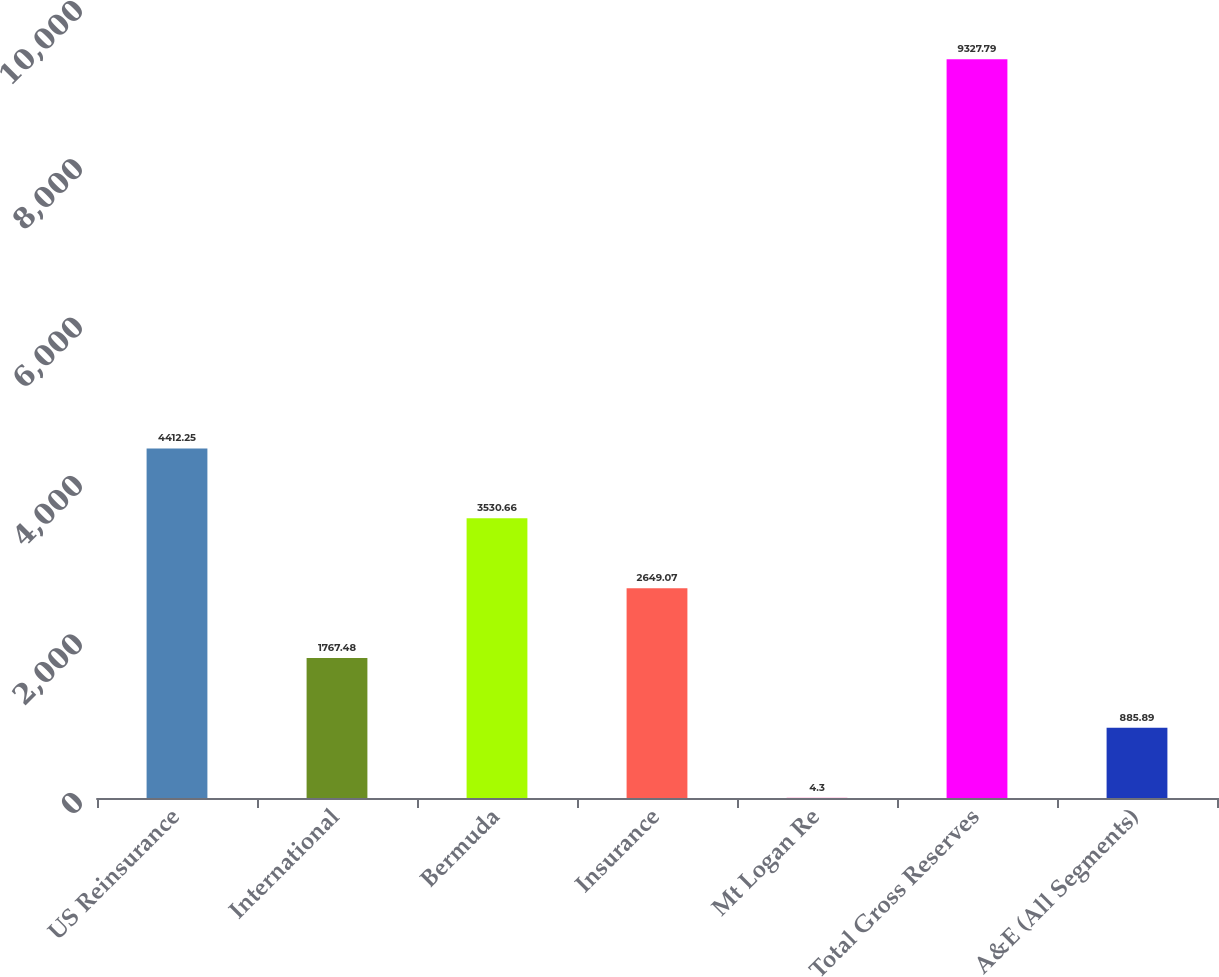<chart> <loc_0><loc_0><loc_500><loc_500><bar_chart><fcel>US Reinsurance<fcel>International<fcel>Bermuda<fcel>Insurance<fcel>Mt Logan Re<fcel>Total Gross Reserves<fcel>A&E (All Segments)<nl><fcel>4412.25<fcel>1767.48<fcel>3530.66<fcel>2649.07<fcel>4.3<fcel>9327.79<fcel>885.89<nl></chart> 